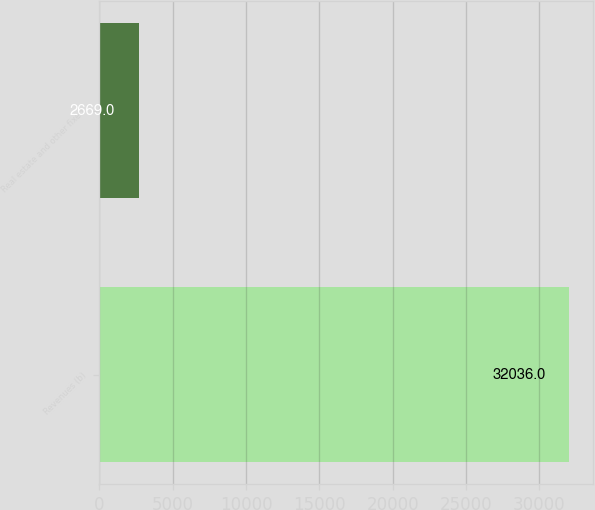<chart> <loc_0><loc_0><loc_500><loc_500><bar_chart><fcel>Revenues (b)<fcel>Real estate and other fixed<nl><fcel>32036<fcel>2669<nl></chart> 